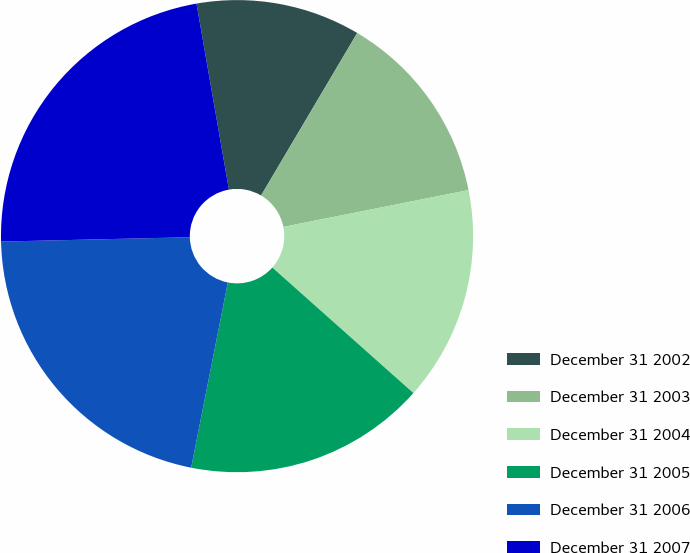Convert chart to OTSL. <chart><loc_0><loc_0><loc_500><loc_500><pie_chart><fcel>December 31 2002<fcel>December 31 2003<fcel>December 31 2004<fcel>December 31 2005<fcel>December 31 2006<fcel>December 31 2007<nl><fcel>11.25%<fcel>13.37%<fcel>14.7%<fcel>16.54%<fcel>21.52%<fcel>22.62%<nl></chart> 